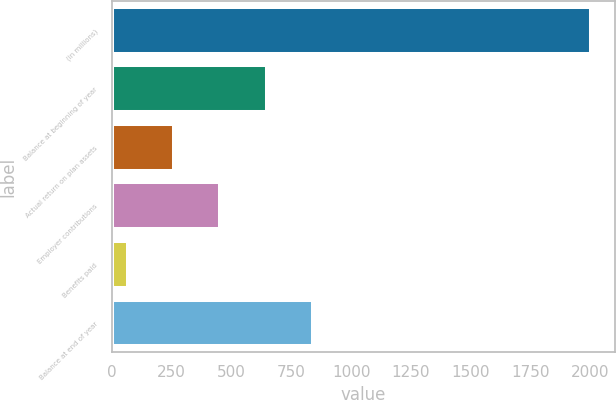Convert chart to OTSL. <chart><loc_0><loc_0><loc_500><loc_500><bar_chart><fcel>(in millions)<fcel>Balance at beginning of year<fcel>Actual return on plan assets<fcel>Employer contributions<fcel>Benefits paid<fcel>Balance at end of year<nl><fcel>2003<fcel>647.1<fcel>259.7<fcel>453.4<fcel>66<fcel>840.8<nl></chart> 